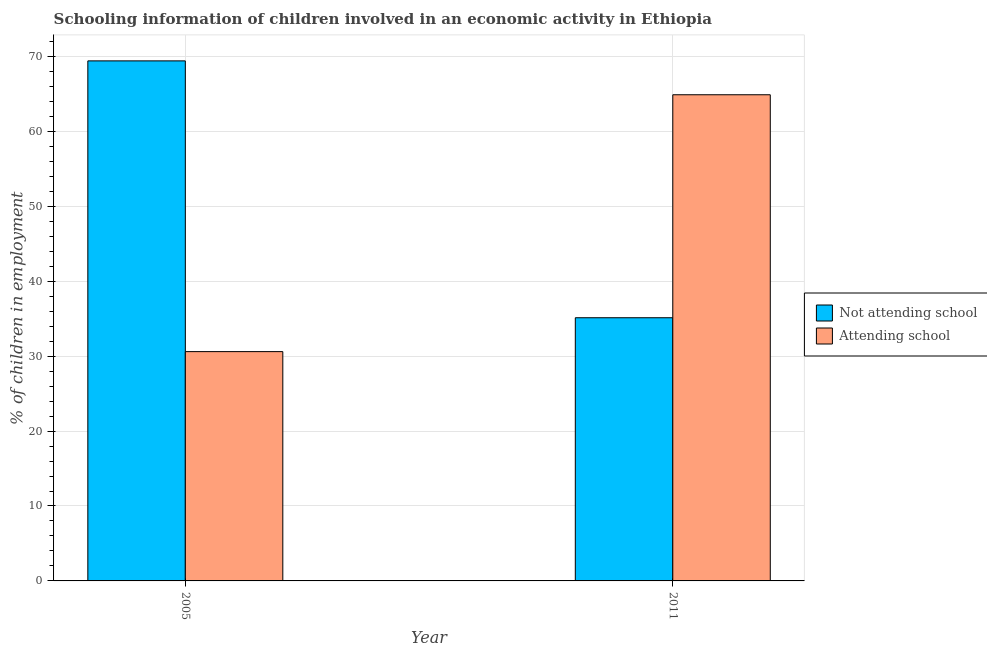How many different coloured bars are there?
Offer a terse response. 2. What is the label of the 1st group of bars from the left?
Provide a short and direct response. 2005. In how many cases, is the number of bars for a given year not equal to the number of legend labels?
Ensure brevity in your answer.  0. What is the percentage of employed children who are attending school in 2011?
Make the answer very short. 64.88. Across all years, what is the maximum percentage of employed children who are attending school?
Ensure brevity in your answer.  64.88. Across all years, what is the minimum percentage of employed children who are not attending school?
Provide a succinct answer. 35.12. In which year was the percentage of employed children who are attending school maximum?
Provide a short and direct response. 2011. What is the total percentage of employed children who are attending school in the graph?
Ensure brevity in your answer.  95.48. What is the difference between the percentage of employed children who are attending school in 2005 and that in 2011?
Provide a succinct answer. -34.28. What is the difference between the percentage of employed children who are attending school in 2011 and the percentage of employed children who are not attending school in 2005?
Provide a short and direct response. 34.28. What is the average percentage of employed children who are attending school per year?
Make the answer very short. 47.74. In the year 2011, what is the difference between the percentage of employed children who are not attending school and percentage of employed children who are attending school?
Offer a very short reply. 0. In how many years, is the percentage of employed children who are not attending school greater than 60 %?
Offer a very short reply. 1. What is the ratio of the percentage of employed children who are not attending school in 2005 to that in 2011?
Your response must be concise. 1.98. Is the percentage of employed children who are attending school in 2005 less than that in 2011?
Give a very brief answer. Yes. What does the 1st bar from the left in 2011 represents?
Ensure brevity in your answer.  Not attending school. What does the 1st bar from the right in 2011 represents?
Provide a succinct answer. Attending school. How many bars are there?
Keep it short and to the point. 4. What is the difference between two consecutive major ticks on the Y-axis?
Your response must be concise. 10. Does the graph contain grids?
Make the answer very short. Yes. Where does the legend appear in the graph?
Make the answer very short. Center right. What is the title of the graph?
Offer a very short reply. Schooling information of children involved in an economic activity in Ethiopia. Does "Taxes on profits and capital gains" appear as one of the legend labels in the graph?
Offer a very short reply. No. What is the label or title of the Y-axis?
Your answer should be very brief. % of children in employment. What is the % of children in employment in Not attending school in 2005?
Give a very brief answer. 69.4. What is the % of children in employment in Attending school in 2005?
Make the answer very short. 30.6. What is the % of children in employment in Not attending school in 2011?
Your answer should be very brief. 35.12. What is the % of children in employment of Attending school in 2011?
Make the answer very short. 64.88. Across all years, what is the maximum % of children in employment of Not attending school?
Give a very brief answer. 69.4. Across all years, what is the maximum % of children in employment in Attending school?
Provide a succinct answer. 64.88. Across all years, what is the minimum % of children in employment of Not attending school?
Your response must be concise. 35.12. Across all years, what is the minimum % of children in employment in Attending school?
Make the answer very short. 30.6. What is the total % of children in employment in Not attending school in the graph?
Your answer should be very brief. 104.52. What is the total % of children in employment of Attending school in the graph?
Offer a very short reply. 95.48. What is the difference between the % of children in employment in Not attending school in 2005 and that in 2011?
Provide a short and direct response. 34.28. What is the difference between the % of children in employment of Attending school in 2005 and that in 2011?
Your response must be concise. -34.28. What is the difference between the % of children in employment in Not attending school in 2005 and the % of children in employment in Attending school in 2011?
Give a very brief answer. 4.52. What is the average % of children in employment in Not attending school per year?
Offer a very short reply. 52.26. What is the average % of children in employment in Attending school per year?
Provide a short and direct response. 47.74. In the year 2005, what is the difference between the % of children in employment in Not attending school and % of children in employment in Attending school?
Offer a terse response. 38.8. In the year 2011, what is the difference between the % of children in employment of Not attending school and % of children in employment of Attending school?
Offer a terse response. -29.76. What is the ratio of the % of children in employment of Not attending school in 2005 to that in 2011?
Your answer should be very brief. 1.98. What is the ratio of the % of children in employment of Attending school in 2005 to that in 2011?
Offer a very short reply. 0.47. What is the difference between the highest and the second highest % of children in employment in Not attending school?
Provide a short and direct response. 34.28. What is the difference between the highest and the second highest % of children in employment in Attending school?
Your answer should be compact. 34.28. What is the difference between the highest and the lowest % of children in employment in Not attending school?
Give a very brief answer. 34.28. What is the difference between the highest and the lowest % of children in employment in Attending school?
Ensure brevity in your answer.  34.28. 